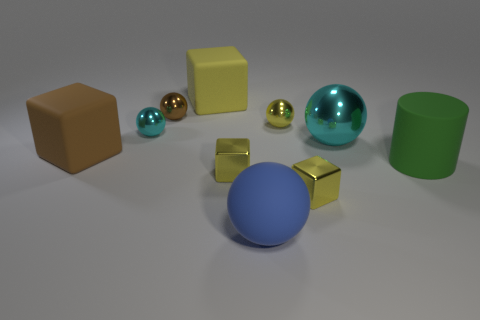Subtract all green spheres. How many yellow blocks are left? 3 Subtract all blue spheres. How many spheres are left? 4 Subtract all yellow rubber cubes. How many cubes are left? 3 Subtract 1 cubes. How many cubes are left? 3 Subtract all blue blocks. Subtract all red cylinders. How many blocks are left? 4 Subtract all cylinders. How many objects are left? 9 Add 1 yellow metallic cylinders. How many yellow metallic cylinders exist? 1 Subtract 0 cyan blocks. How many objects are left? 10 Subtract all tiny spheres. Subtract all cylinders. How many objects are left? 6 Add 5 large brown matte objects. How many large brown matte objects are left? 6 